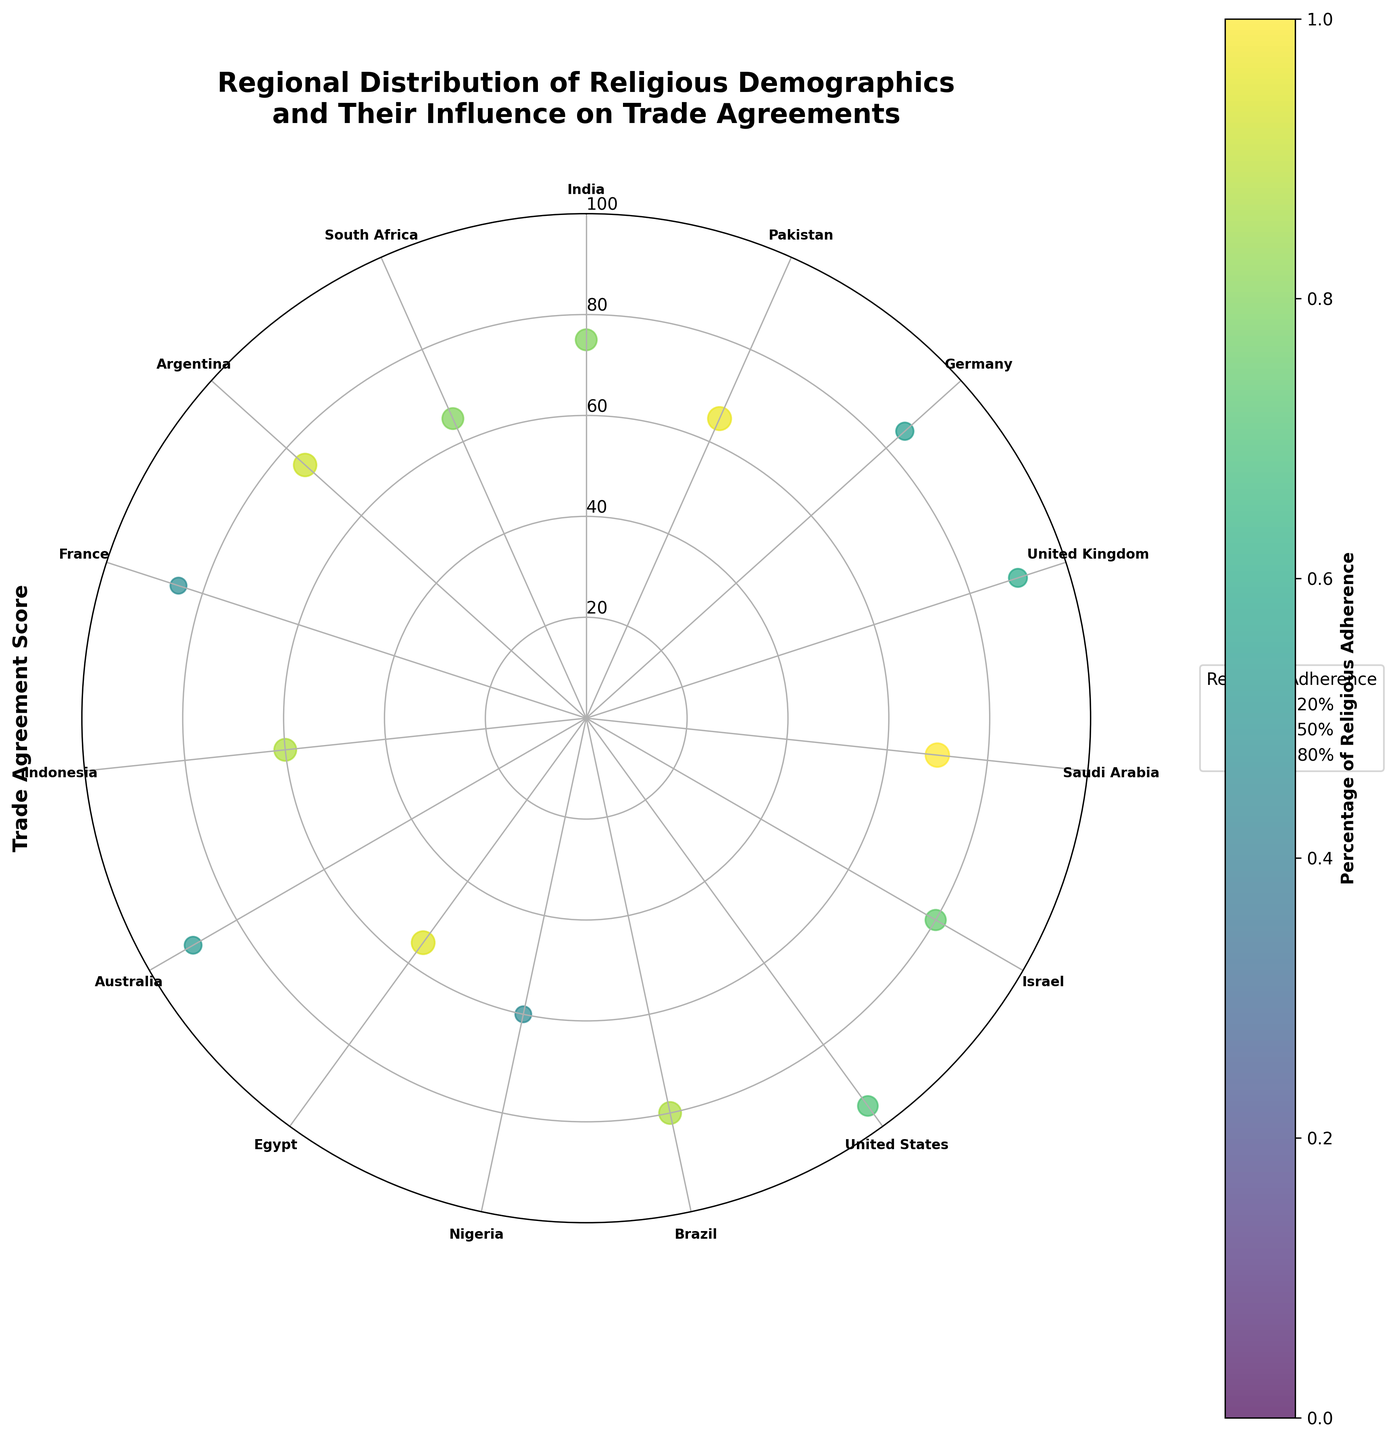What is the title of the plot? The title is typically displayed at the top of the figure. By looking at the top of the chart, we can see the wording of the title.
Answer: Regional Distribution of Religious Demographics and Their Influence on Trade Agreements How many countries are represented in the plot? By counting the ticks or names around the polar plot, we can determine the number of countries included.
Answer: 15 Which region has the country with the highest trade agreement score? Look at the trade agreement scores (distance from center) and identify the highest. Then, check the corresponding region of that country located on the outer ring of the plot.
Answer: North America (United States) Which country has the lowest trade agreement score, and what is their religious percentage? Locate the point closest to the center (lowest score). Then check the color and size to determine the religious percentage of that country.
Answer: Egypt, 94.7% How does the trade agreement score of Germany compare to that of Brazil? Identify points for Germany and Brazil, then compare their distances from the center.
Answer: Germany has a higher trade agreement score than Brazil What is the average trade agreement score of European countries? Identify the countries from Europe, sum their trade agreement scores and divide by the number of European countries.
Answer: (85 + 90 + 85) / 3 = 86.67 Which country in Asia has the highest trade agreement score, and what is its religion? Identify Asian countries and find the one with the greatest distance from the center. Check the corresponding religion.
Answer: India, Hinduism How does the trade agreement score for countries with over 90% religious adherence compare across different regions? Identify countries with religious adherence over 90%, check their regions, and compare their distances from the center.
Answer: India (Asia) 75, Pakistan (Asia) 65, Saudi Arabia (Middle East) 70, Argentina (South America) 75 What is the relation between the size of the bubbles and the religious percentage? The size of the bubbles reflects the religious percentage. Larger bubbles denote a higher percentage of religious adherence.
Answer: Larger bubbles indicate a higher percentage of religious adherence Do the countries in Africa generally have higher or lower trade agreement scores compared to countries in the Middle East? Identify countries in Africa and the Middle East, compare their trade agreement scores by visually inspecting positions in the polar chart.
Answer: Countries in Africa generally have lower trade agreement scores compared to those in the Middle East 